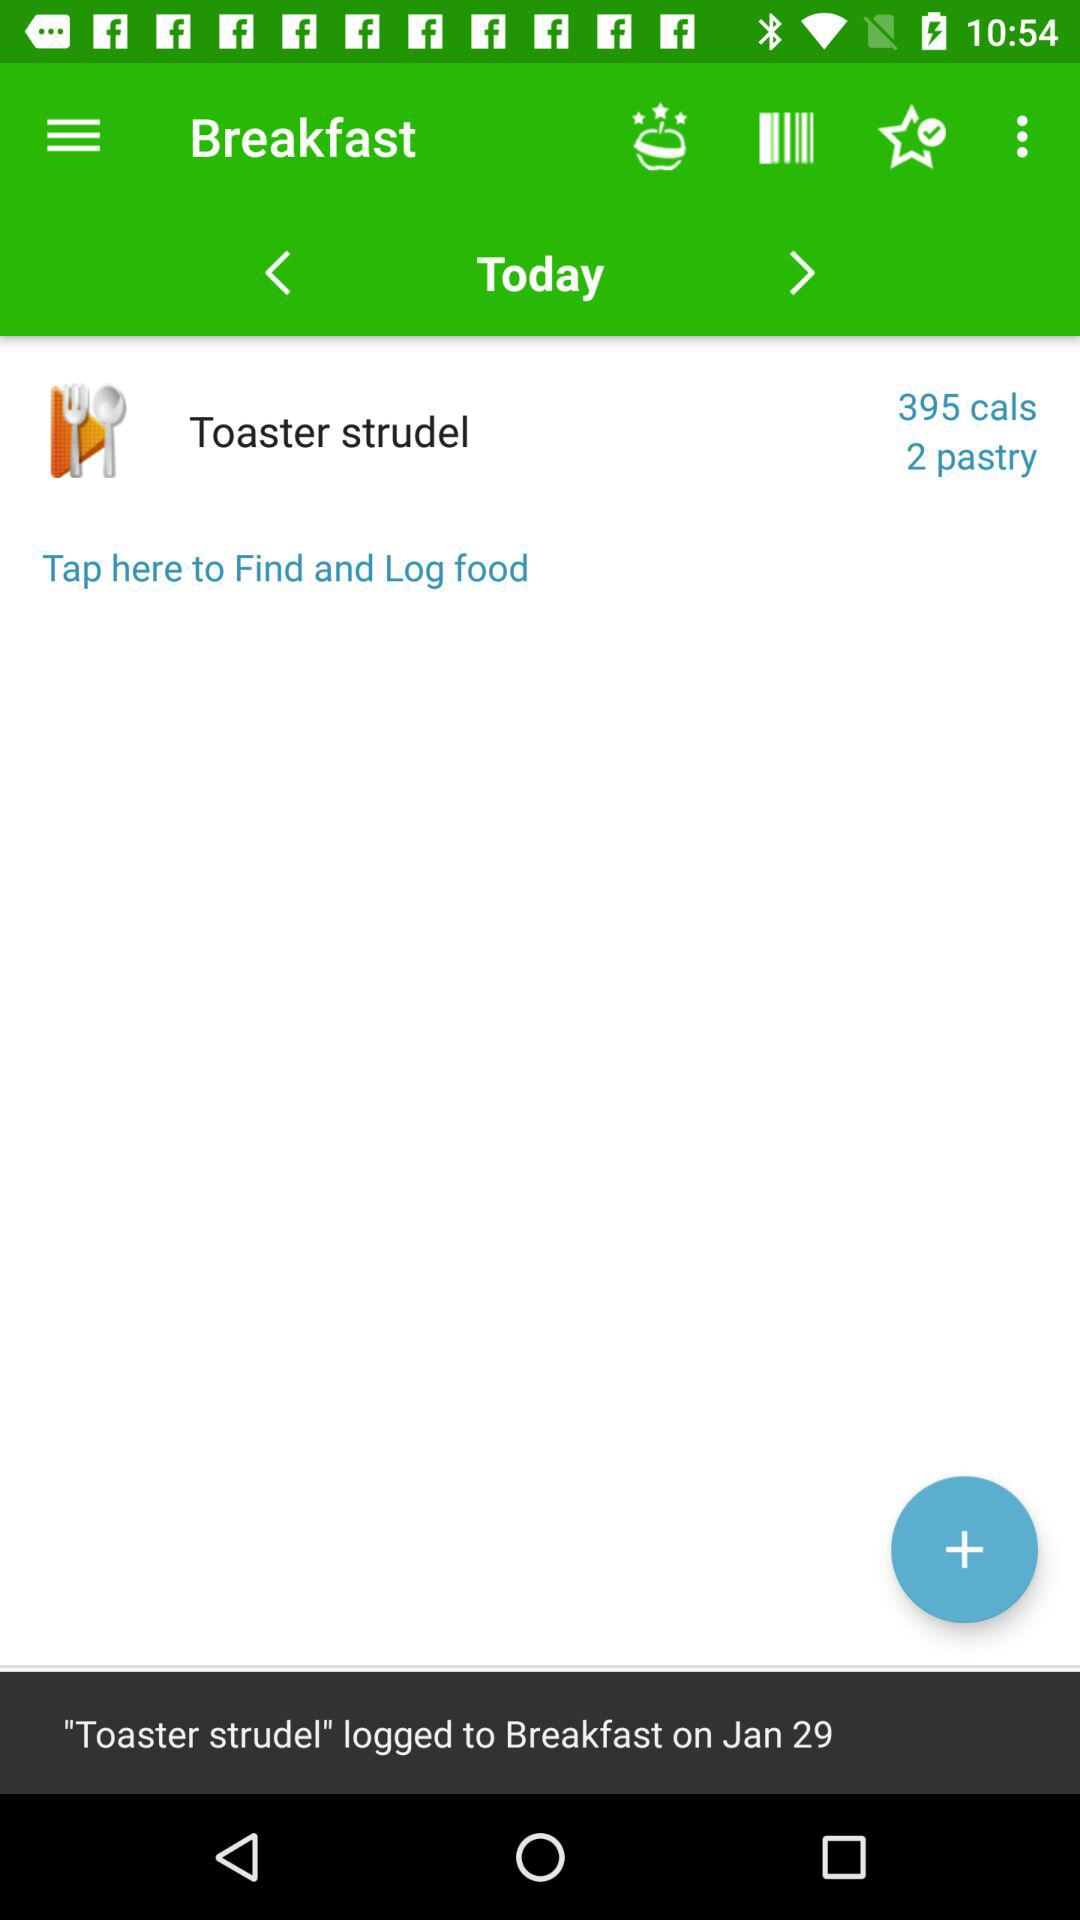How many "Toaster Strudel" pastries come in one serving?
When the provided information is insufficient, respond with <no answer>. <no answer> 